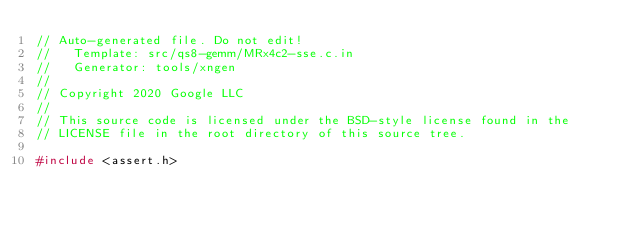Convert code to text. <code><loc_0><loc_0><loc_500><loc_500><_C_>// Auto-generated file. Do not edit!
//   Template: src/qs8-gemm/MRx4c2-sse.c.in
//   Generator: tools/xngen
//
// Copyright 2020 Google LLC
//
// This source code is licensed under the BSD-style license found in the
// LICENSE file in the root directory of this source tree.

#include <assert.h>
</code> 